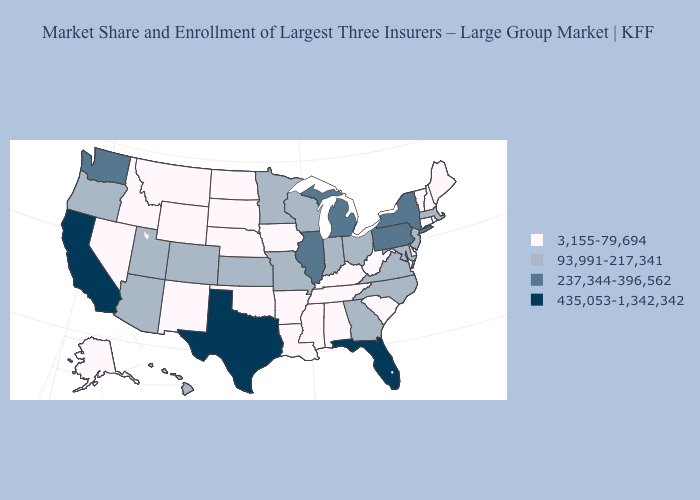Name the states that have a value in the range 3,155-79,694?
Short answer required. Alabama, Alaska, Arkansas, Connecticut, Delaware, Idaho, Iowa, Kentucky, Louisiana, Maine, Mississippi, Montana, Nebraska, Nevada, New Hampshire, New Mexico, North Dakota, Oklahoma, Rhode Island, South Carolina, South Dakota, Tennessee, Vermont, West Virginia, Wyoming. Among the states that border Georgia , which have the lowest value?
Give a very brief answer. Alabama, South Carolina, Tennessee. What is the lowest value in states that border Colorado?
Quick response, please. 3,155-79,694. Does Oregon have the lowest value in the USA?
Keep it brief. No. Does Arkansas have a lower value than Kansas?
Quick response, please. Yes. Is the legend a continuous bar?
Give a very brief answer. No. What is the lowest value in states that border California?
Keep it brief. 3,155-79,694. Among the states that border West Virginia , does Virginia have the highest value?
Quick response, please. No. Does Texas have the highest value in the South?
Give a very brief answer. Yes. Does California have the highest value in the USA?
Concise answer only. Yes. Name the states that have a value in the range 237,344-396,562?
Answer briefly. Illinois, Michigan, New York, Pennsylvania, Washington. Name the states that have a value in the range 3,155-79,694?
Be succinct. Alabama, Alaska, Arkansas, Connecticut, Delaware, Idaho, Iowa, Kentucky, Louisiana, Maine, Mississippi, Montana, Nebraska, Nevada, New Hampshire, New Mexico, North Dakota, Oklahoma, Rhode Island, South Carolina, South Dakota, Tennessee, Vermont, West Virginia, Wyoming. What is the value of Wyoming?
Short answer required. 3,155-79,694. Which states have the lowest value in the USA?
Keep it brief. Alabama, Alaska, Arkansas, Connecticut, Delaware, Idaho, Iowa, Kentucky, Louisiana, Maine, Mississippi, Montana, Nebraska, Nevada, New Hampshire, New Mexico, North Dakota, Oklahoma, Rhode Island, South Carolina, South Dakota, Tennessee, Vermont, West Virginia, Wyoming. Which states hav the highest value in the MidWest?
Be succinct. Illinois, Michigan. 